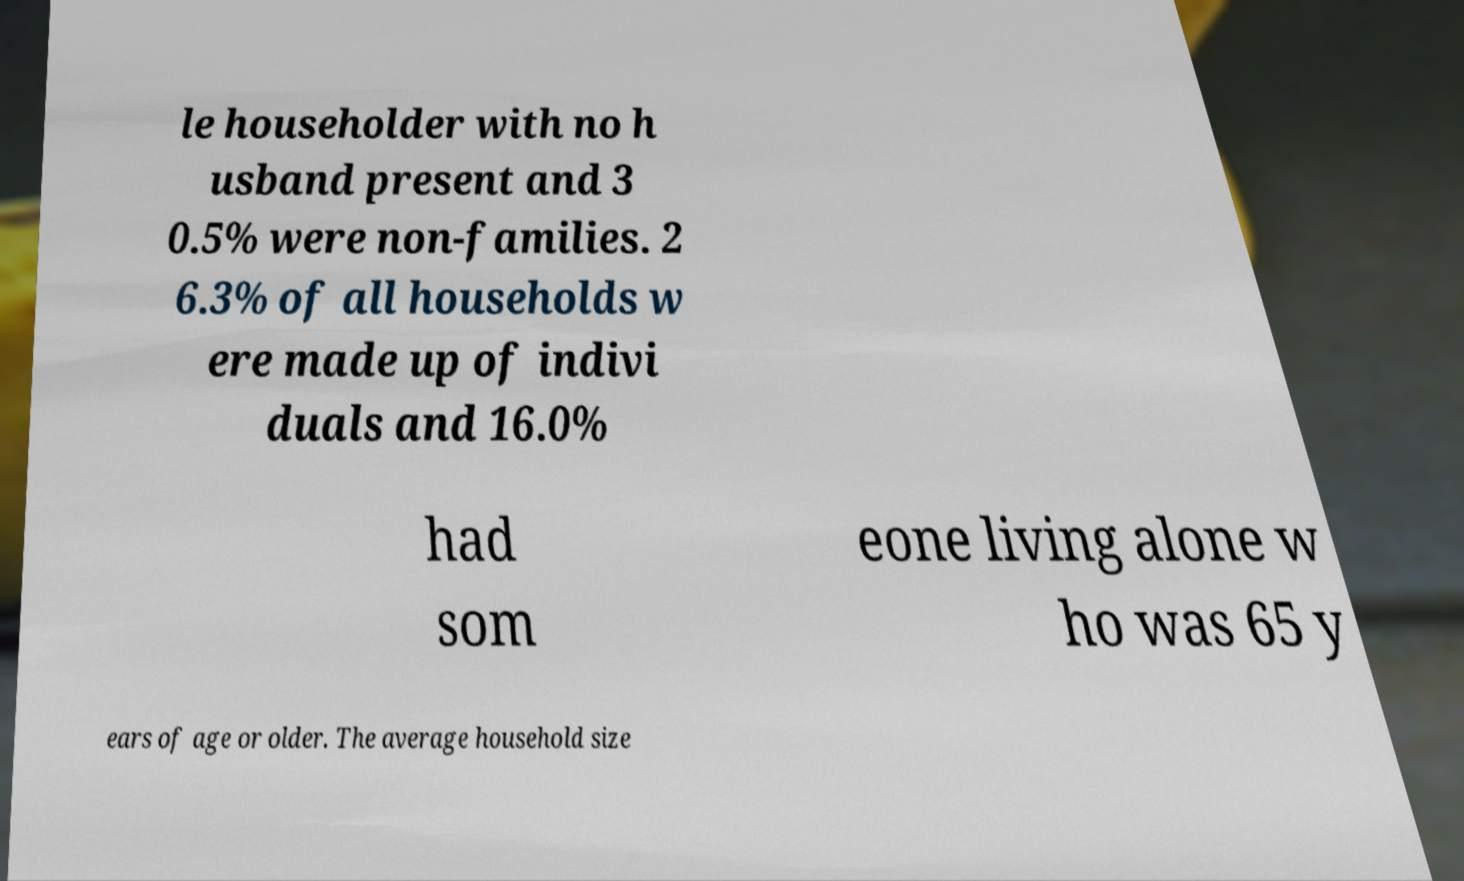Can you accurately transcribe the text from the provided image for me? le householder with no h usband present and 3 0.5% were non-families. 2 6.3% of all households w ere made up of indivi duals and 16.0% had som eone living alone w ho was 65 y ears of age or older. The average household size 